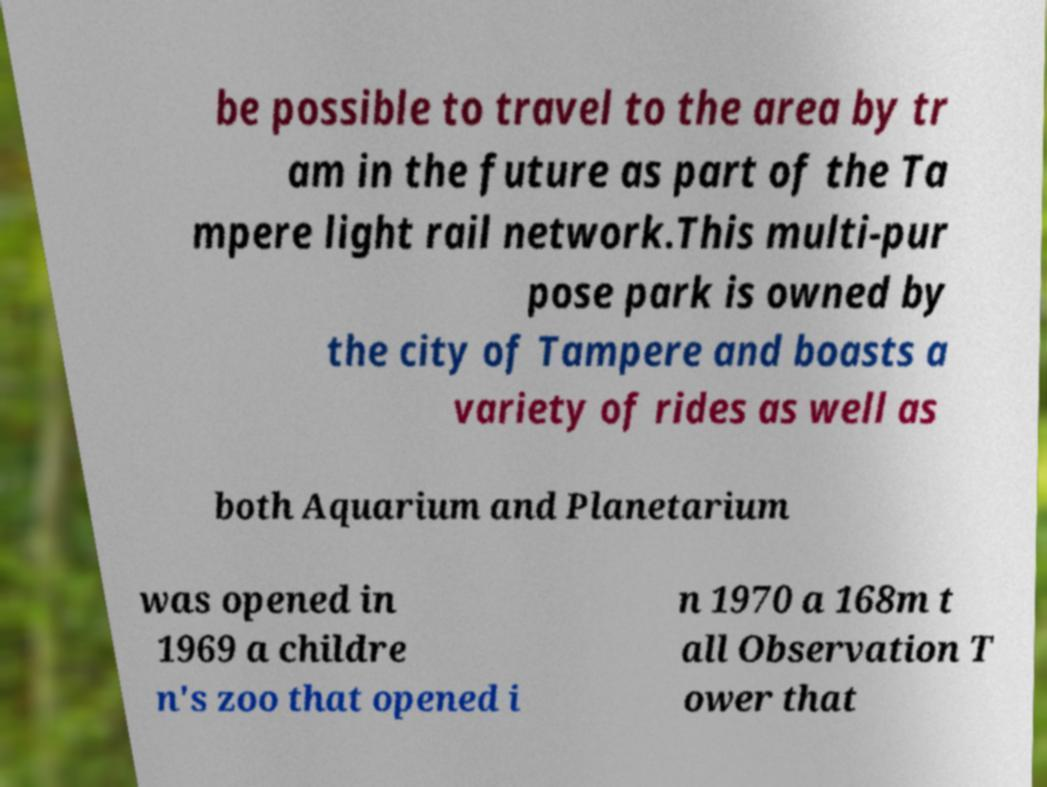There's text embedded in this image that I need extracted. Can you transcribe it verbatim? be possible to travel to the area by tr am in the future as part of the Ta mpere light rail network.This multi-pur pose park is owned by the city of Tampere and boasts a variety of rides as well as both Aquarium and Planetarium was opened in 1969 a childre n's zoo that opened i n 1970 a 168m t all Observation T ower that 